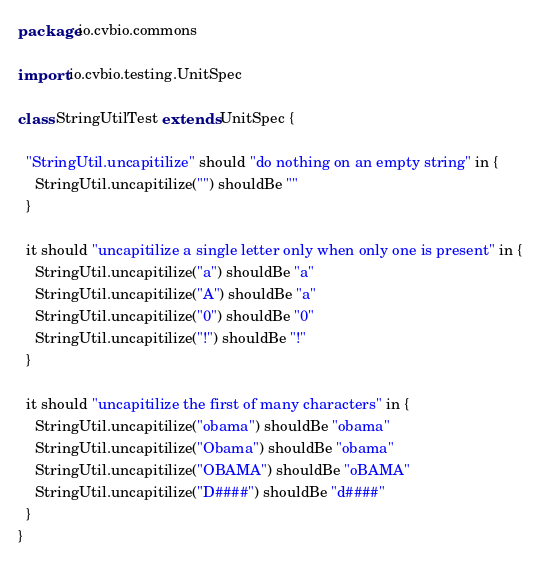<code> <loc_0><loc_0><loc_500><loc_500><_Scala_>package io.cvbio.commons

import io.cvbio.testing.UnitSpec

class StringUtilTest extends UnitSpec {

  "StringUtil.uncapitilize" should "do nothing on an empty string" in {
    StringUtil.uncapitilize("") shouldBe ""
  }

  it should "uncapitilize a single letter only when only one is present" in {
    StringUtil.uncapitilize("a") shouldBe "a"
    StringUtil.uncapitilize("A") shouldBe "a"
    StringUtil.uncapitilize("0") shouldBe "0"
    StringUtil.uncapitilize("!") shouldBe "!"
  }

  it should "uncapitilize the first of many characters" in {
    StringUtil.uncapitilize("obama") shouldBe "obama"
    StringUtil.uncapitilize("Obama") shouldBe "obama"
    StringUtil.uncapitilize("OBAMA") shouldBe "oBAMA"
    StringUtil.uncapitilize("D####") shouldBe "d####"
  }
}
</code> 